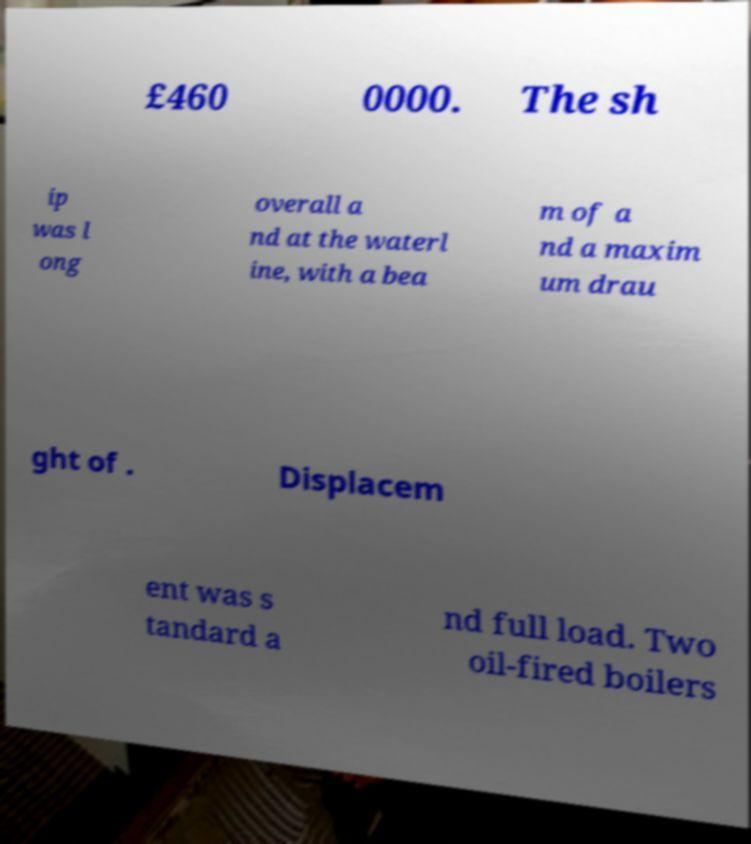Could you assist in decoding the text presented in this image and type it out clearly? £460 0000. The sh ip was l ong overall a nd at the waterl ine, with a bea m of a nd a maxim um drau ght of . Displacem ent was s tandard a nd full load. Two oil-fired boilers 